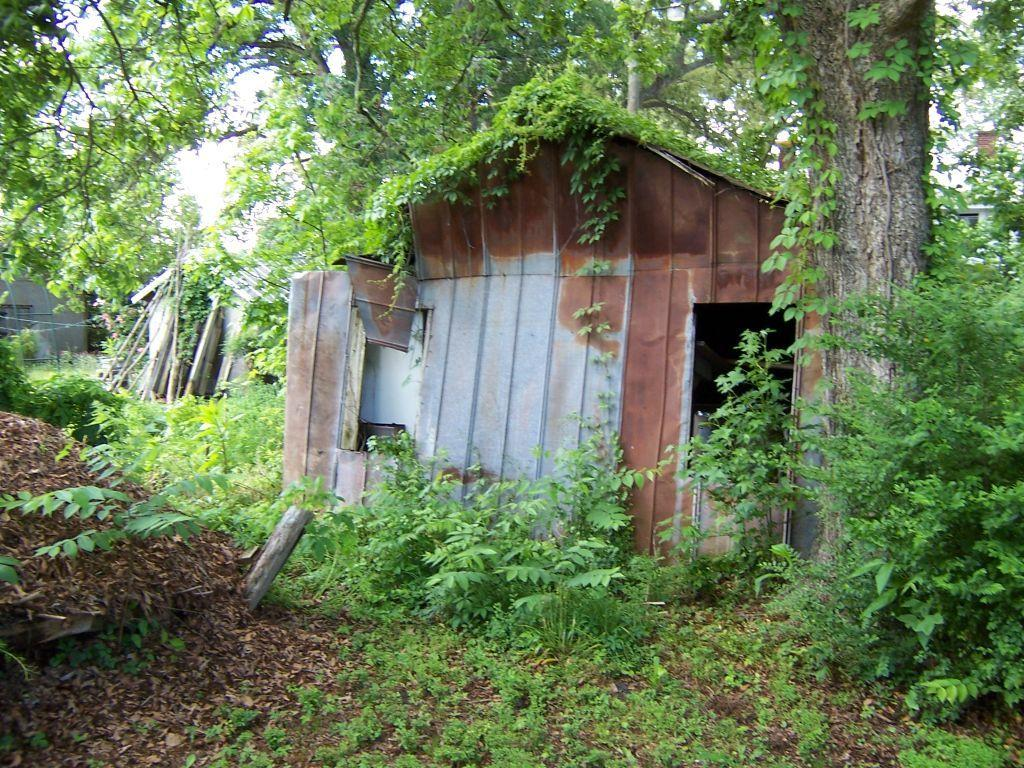What type of structures can be seen in the image? There are houses in the image. What can be seen in the background of the image? There are plants, trees, sticks, and the sky visible in the background of the image. What type of baby can be seen playing with the process in the image? There is no baby or process present in the image. What season is depicted in the image, considering the presence of spring flowers? There is no mention of spring flowers or any specific season in the image; only plants, trees, and sticks are visible. 